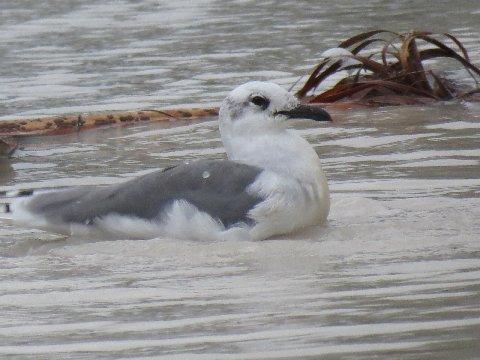How many birds are there?
Give a very brief answer. 1. 